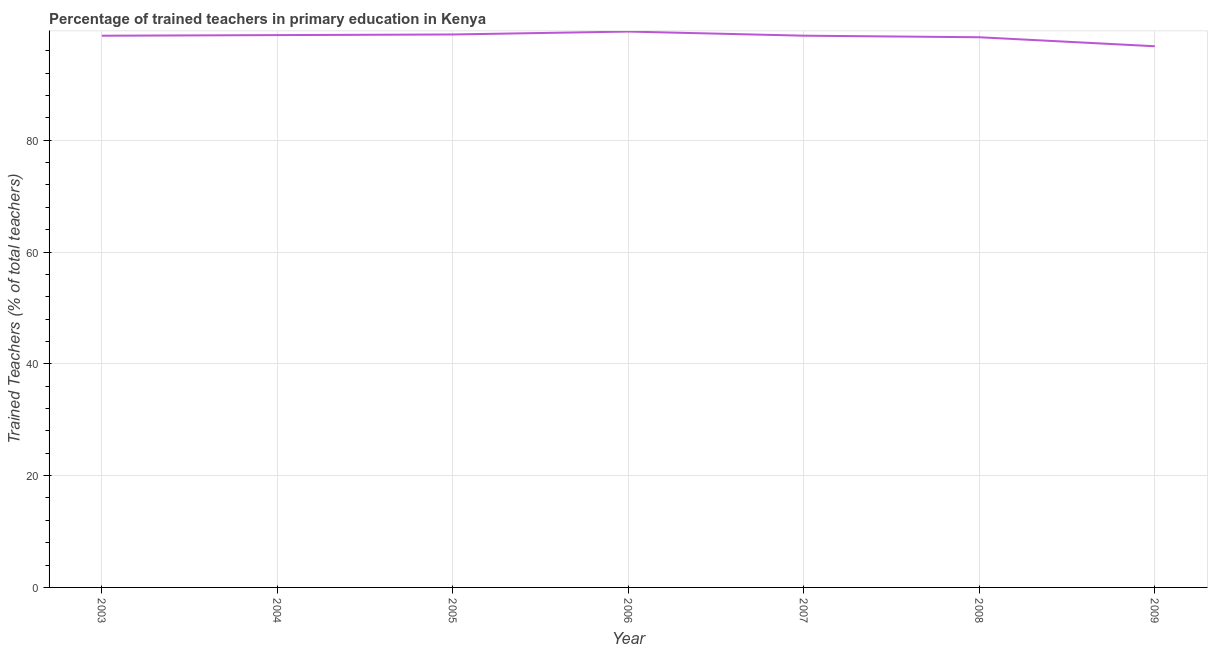What is the percentage of trained teachers in 2009?
Make the answer very short. 96.81. Across all years, what is the maximum percentage of trained teachers?
Provide a short and direct response. 99.43. Across all years, what is the minimum percentage of trained teachers?
Ensure brevity in your answer.  96.81. In which year was the percentage of trained teachers minimum?
Provide a succinct answer. 2009. What is the sum of the percentage of trained teachers?
Your response must be concise. 689.76. What is the difference between the percentage of trained teachers in 2003 and 2005?
Your answer should be compact. -0.22. What is the average percentage of trained teachers per year?
Your response must be concise. 98.54. What is the median percentage of trained teachers?
Give a very brief answer. 98.7. What is the ratio of the percentage of trained teachers in 2005 to that in 2007?
Your answer should be compact. 1. Is the difference between the percentage of trained teachers in 2004 and 2008 greater than the difference between any two years?
Your answer should be very brief. No. What is the difference between the highest and the second highest percentage of trained teachers?
Offer a very short reply. 0.52. What is the difference between the highest and the lowest percentage of trained teachers?
Your response must be concise. 2.63. How many lines are there?
Provide a short and direct response. 1. What is the difference between two consecutive major ticks on the Y-axis?
Provide a succinct answer. 20. Are the values on the major ticks of Y-axis written in scientific E-notation?
Your answer should be very brief. No. What is the title of the graph?
Your answer should be very brief. Percentage of trained teachers in primary education in Kenya. What is the label or title of the Y-axis?
Ensure brevity in your answer.  Trained Teachers (% of total teachers). What is the Trained Teachers (% of total teachers) in 2003?
Your answer should be compact. 98.69. What is the Trained Teachers (% of total teachers) in 2004?
Make the answer very short. 98.8. What is the Trained Teachers (% of total teachers) in 2005?
Your response must be concise. 98.91. What is the Trained Teachers (% of total teachers) of 2006?
Offer a terse response. 99.43. What is the Trained Teachers (% of total teachers) in 2007?
Ensure brevity in your answer.  98.7. What is the Trained Teachers (% of total teachers) of 2008?
Give a very brief answer. 98.42. What is the Trained Teachers (% of total teachers) in 2009?
Provide a succinct answer. 96.81. What is the difference between the Trained Teachers (% of total teachers) in 2003 and 2004?
Your answer should be very brief. -0.11. What is the difference between the Trained Teachers (% of total teachers) in 2003 and 2005?
Offer a terse response. -0.22. What is the difference between the Trained Teachers (% of total teachers) in 2003 and 2006?
Offer a very short reply. -0.74. What is the difference between the Trained Teachers (% of total teachers) in 2003 and 2007?
Make the answer very short. -0. What is the difference between the Trained Teachers (% of total teachers) in 2003 and 2008?
Keep it short and to the point. 0.28. What is the difference between the Trained Teachers (% of total teachers) in 2003 and 2009?
Make the answer very short. 1.88. What is the difference between the Trained Teachers (% of total teachers) in 2004 and 2005?
Your answer should be very brief. -0.11. What is the difference between the Trained Teachers (% of total teachers) in 2004 and 2006?
Keep it short and to the point. -0.63. What is the difference between the Trained Teachers (% of total teachers) in 2004 and 2007?
Provide a succinct answer. 0.1. What is the difference between the Trained Teachers (% of total teachers) in 2004 and 2008?
Keep it short and to the point. 0.38. What is the difference between the Trained Teachers (% of total teachers) in 2004 and 2009?
Provide a succinct answer. 1.99. What is the difference between the Trained Teachers (% of total teachers) in 2005 and 2006?
Offer a very short reply. -0.52. What is the difference between the Trained Teachers (% of total teachers) in 2005 and 2007?
Your answer should be very brief. 0.22. What is the difference between the Trained Teachers (% of total teachers) in 2005 and 2008?
Your response must be concise. 0.5. What is the difference between the Trained Teachers (% of total teachers) in 2005 and 2009?
Make the answer very short. 2.11. What is the difference between the Trained Teachers (% of total teachers) in 2006 and 2007?
Your answer should be compact. 0.74. What is the difference between the Trained Teachers (% of total teachers) in 2006 and 2008?
Offer a terse response. 1.02. What is the difference between the Trained Teachers (% of total teachers) in 2006 and 2009?
Your answer should be compact. 2.63. What is the difference between the Trained Teachers (% of total teachers) in 2007 and 2008?
Make the answer very short. 0.28. What is the difference between the Trained Teachers (% of total teachers) in 2007 and 2009?
Offer a terse response. 1.89. What is the difference between the Trained Teachers (% of total teachers) in 2008 and 2009?
Your answer should be compact. 1.61. What is the ratio of the Trained Teachers (% of total teachers) in 2003 to that in 2005?
Make the answer very short. 1. What is the ratio of the Trained Teachers (% of total teachers) in 2003 to that in 2006?
Your response must be concise. 0.99. What is the ratio of the Trained Teachers (% of total teachers) in 2003 to that in 2009?
Ensure brevity in your answer.  1.02. What is the ratio of the Trained Teachers (% of total teachers) in 2004 to that in 2005?
Your response must be concise. 1. What is the ratio of the Trained Teachers (% of total teachers) in 2004 to that in 2006?
Offer a terse response. 0.99. What is the ratio of the Trained Teachers (% of total teachers) in 2004 to that in 2008?
Ensure brevity in your answer.  1. What is the ratio of the Trained Teachers (% of total teachers) in 2005 to that in 2007?
Your response must be concise. 1. What is the ratio of the Trained Teachers (% of total teachers) in 2005 to that in 2008?
Offer a very short reply. 1. What is the ratio of the Trained Teachers (% of total teachers) in 2006 to that in 2007?
Make the answer very short. 1.01. What is the ratio of the Trained Teachers (% of total teachers) in 2006 to that in 2009?
Keep it short and to the point. 1.03. 